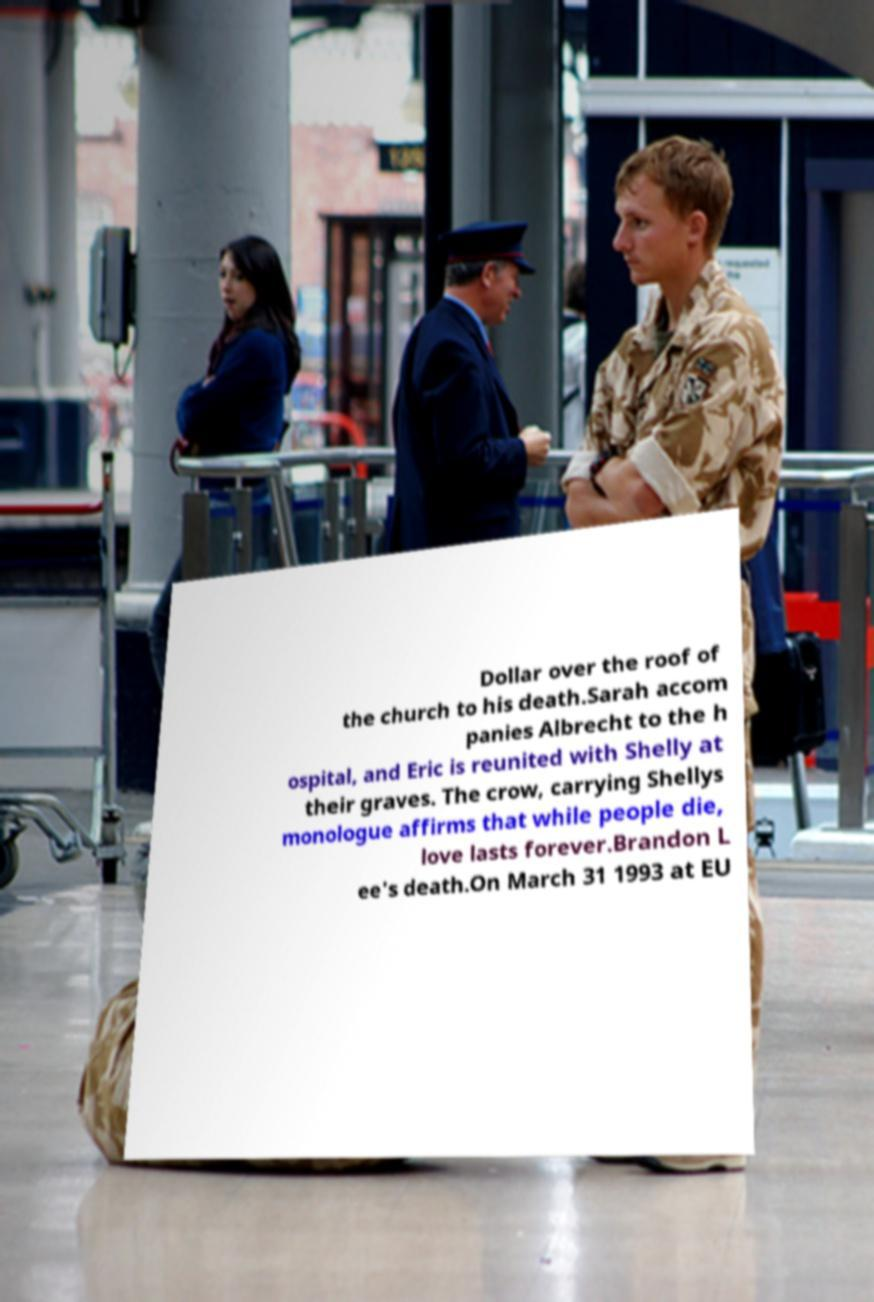There's text embedded in this image that I need extracted. Can you transcribe it verbatim? Dollar over the roof of the church to his death.Sarah accom panies Albrecht to the h ospital, and Eric is reunited with Shelly at their graves. The crow, carrying Shellys monologue affirms that while people die, love lasts forever.Brandon L ee's death.On March 31 1993 at EU 